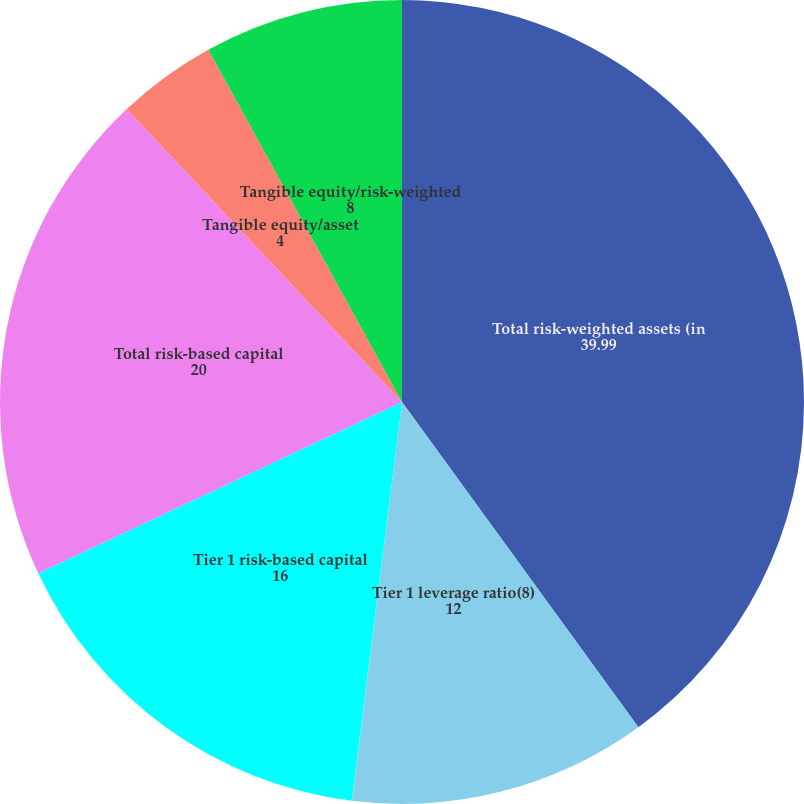<chart> <loc_0><loc_0><loc_500><loc_500><pie_chart><fcel>Total risk-weighted assets (in<fcel>Tier 1 leverage ratio(8)<fcel>Tier 1 risk-based capital<fcel>Total risk-based capital<fcel>Tangible common equity/asset<fcel>Tangible equity/asset<fcel>Tangible equity/risk-weighted<nl><fcel>39.99%<fcel>12.0%<fcel>16.0%<fcel>20.0%<fcel>0.0%<fcel>4.0%<fcel>8.0%<nl></chart> 